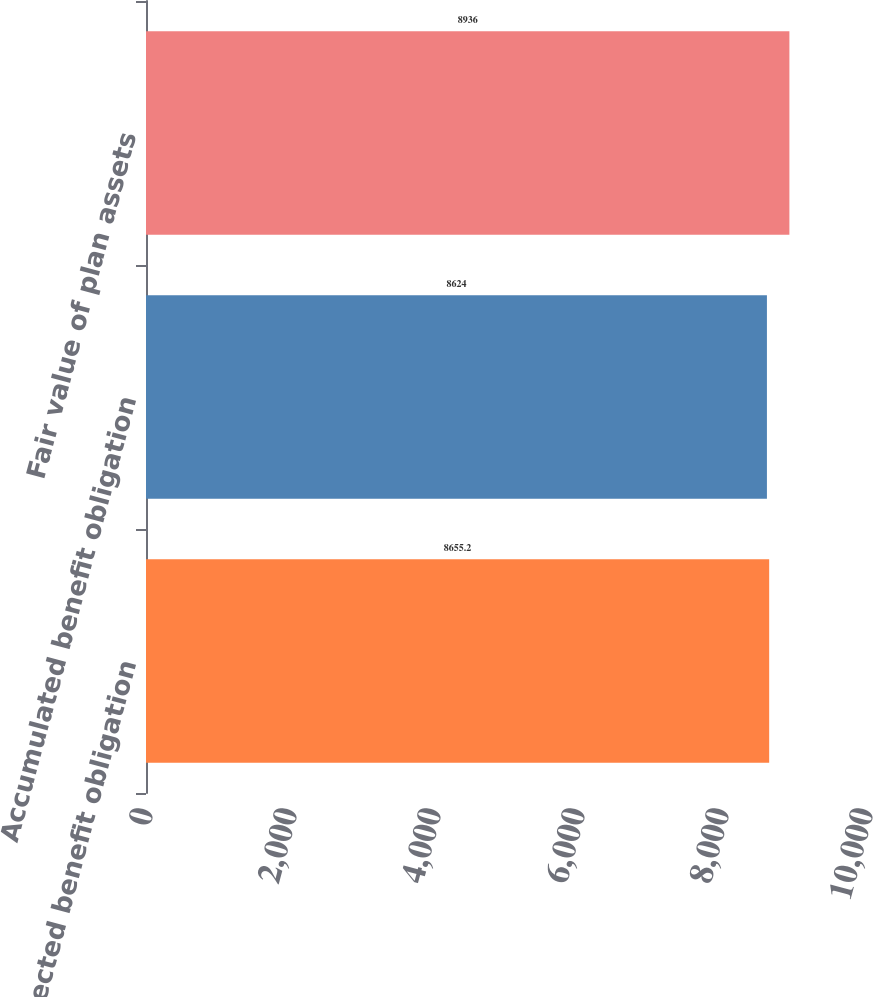<chart> <loc_0><loc_0><loc_500><loc_500><bar_chart><fcel>Projected benefit obligation<fcel>Accumulated benefit obligation<fcel>Fair value of plan assets<nl><fcel>8655.2<fcel>8624<fcel>8936<nl></chart> 